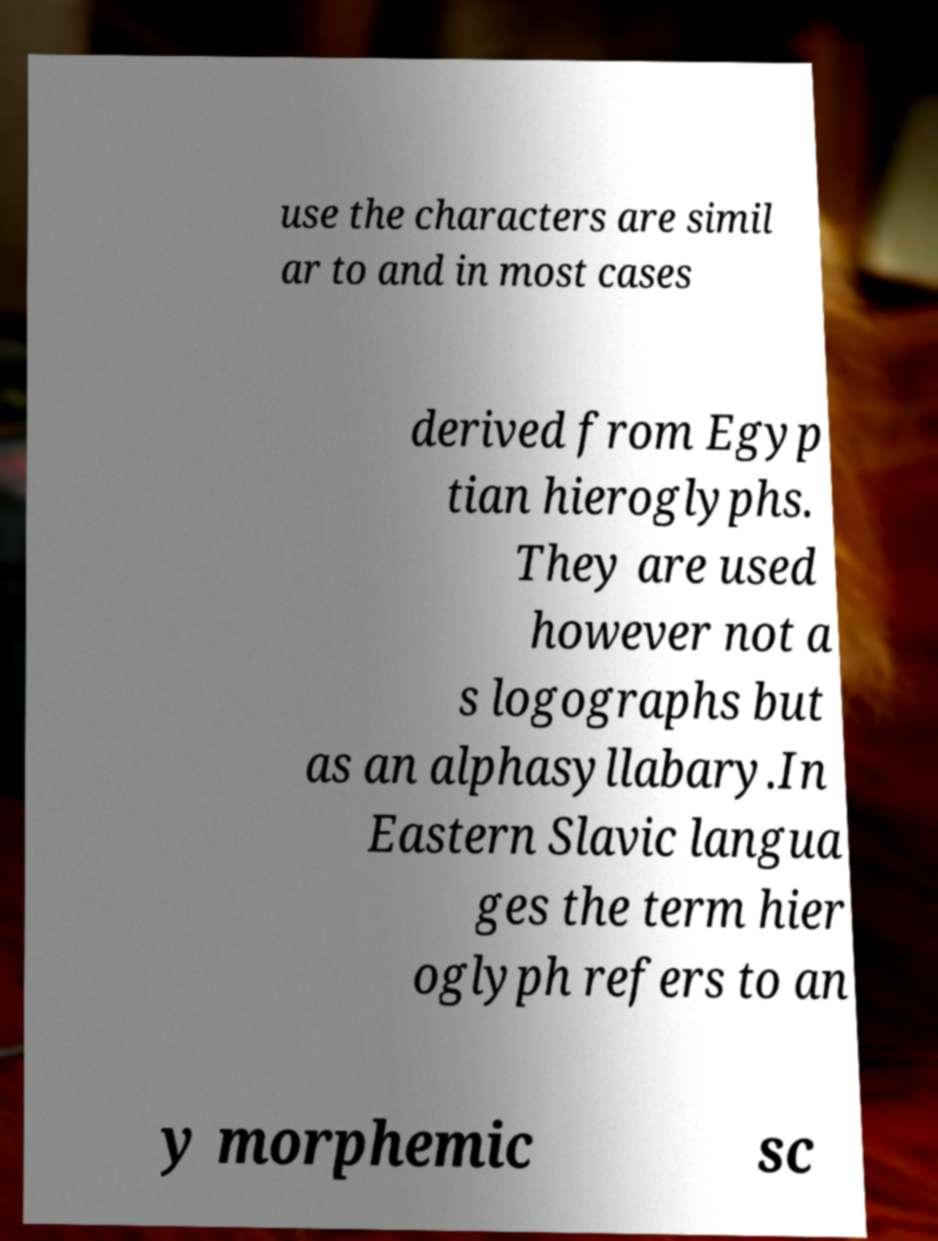Can you accurately transcribe the text from the provided image for me? use the characters are simil ar to and in most cases derived from Egyp tian hieroglyphs. They are used however not a s logographs but as an alphasyllabary.In Eastern Slavic langua ges the term hier oglyph refers to an y morphemic sc 